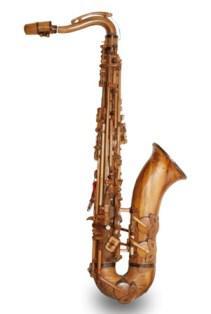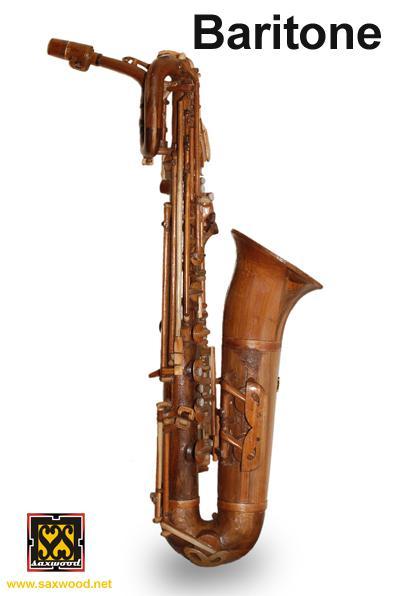The first image is the image on the left, the second image is the image on the right. Assess this claim about the two images: "One of the images contains at least two saxophones.". Correct or not? Answer yes or no. No. 